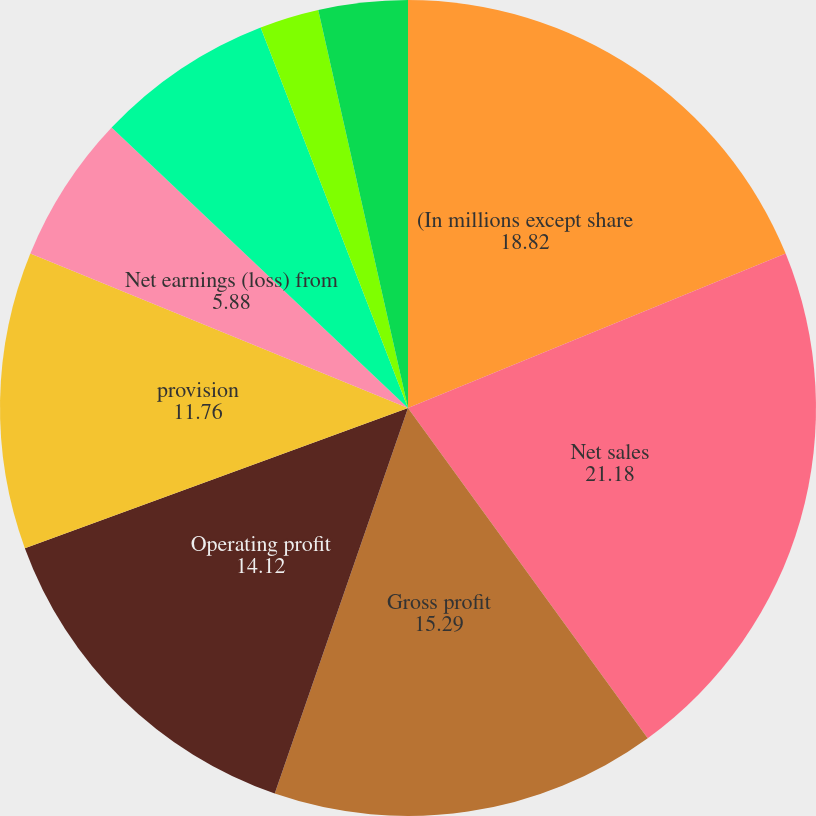Convert chart to OTSL. <chart><loc_0><loc_0><loc_500><loc_500><pie_chart><fcel>(In millions except share<fcel>Net sales<fcel>Gross profit<fcel>Operating profit<fcel>provision<fcel>Net earnings (loss) from<fcel>Net earnings from discontinued<fcel>Continuing operations<fcel>Discontinued operations (1)(2)<fcel>Net earnings per common<nl><fcel>18.82%<fcel>21.18%<fcel>15.29%<fcel>14.12%<fcel>11.76%<fcel>5.88%<fcel>7.06%<fcel>0.0%<fcel>2.35%<fcel>3.53%<nl></chart> 